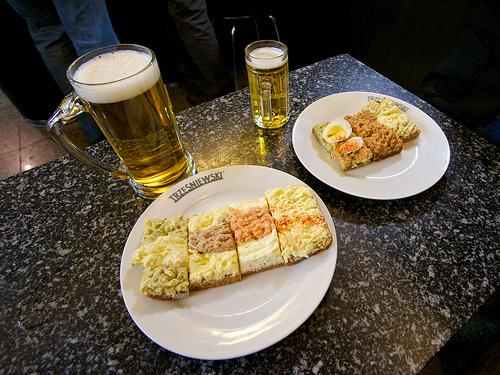Question: what is Trzesniewski?
Choices:
A. A restaurant.
B. Jewelry brand.
C. An author.
D. Clothes brand.
Answer with the letter. Answer: A Question: who is in the restaurant?
Choices:
A. A group of friends.
B. A family.
C. A couple.
D. People.
Answer with the letter. Answer: D Question: what is the food?
Choices:
A. Sandwiches.
B. Fried chicken.
C. Crab legs.
D. Salad.
Answer with the letter. Answer: A Question: what is the table top?
Choices:
A. Wood.
B. Granite.
C. Laminate.
D. Plastic.
Answer with the letter. Answer: B Question: what is in the mugs?
Choices:
A. Beer.
B. Milk.
C. Coffee.
D. Juice.
Answer with the letter. Answer: A 